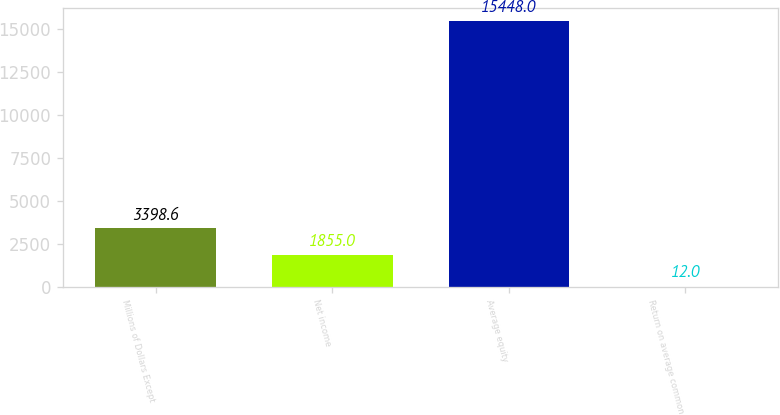<chart> <loc_0><loc_0><loc_500><loc_500><bar_chart><fcel>Millions of Dollars Except<fcel>Net income<fcel>Average equity<fcel>Return on average common<nl><fcel>3398.6<fcel>1855<fcel>15448<fcel>12<nl></chart> 